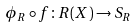Convert formula to latex. <formula><loc_0><loc_0><loc_500><loc_500>\phi _ { R } \circ f \colon R ( X ) \rightarrow S _ { R }</formula> 